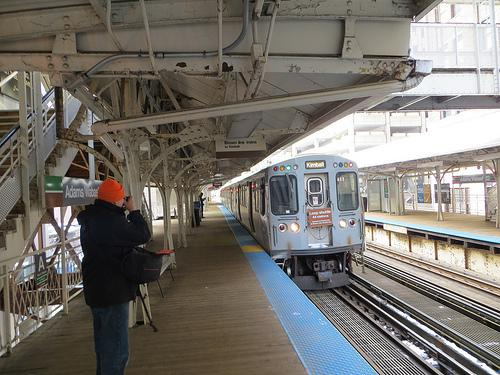Question: what is the man doing in the picture?
Choices:
A. Taking a picture.
B. Taking an eye exam.
C. Scratching an itch.
D. Sneezing.
Answer with the letter. Answer: A Question: who is wearing a orange hat?
Choices:
A. A woman.
B. A child.
C. A man.
D. A cat.
Answer with the letter. Answer: C Question: how many people are in the picture?
Choices:
A. One.
B. Two.
C. Three.
D. Four.
Answer with the letter. Answer: B Question: why is the main taking a picture?
Choices:
A. For a self-portrait.
B. To have evidence of a crime.
C. To capture his family on vacation.
D. To capture the train.
Answer with the letter. Answer: D Question: when was the picture taken?
Choices:
A. Summer.
B. During the day.
C. Winter.
D. Autumn.
Answer with the letter. Answer: B 